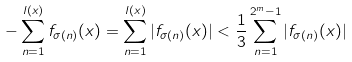Convert formula to latex. <formula><loc_0><loc_0><loc_500><loc_500>- \sum _ { n = 1 } ^ { l ( x ) } f _ { \sigma ( n ) } ( x ) = \sum _ { n = 1 } ^ { l ( x ) } | f _ { \sigma ( n ) } ( x ) | < \frac { 1 } { 3 } \sum _ { n = 1 } ^ { 2 ^ { m } - 1 } | f _ { \sigma ( n ) } ( x ) |</formula> 